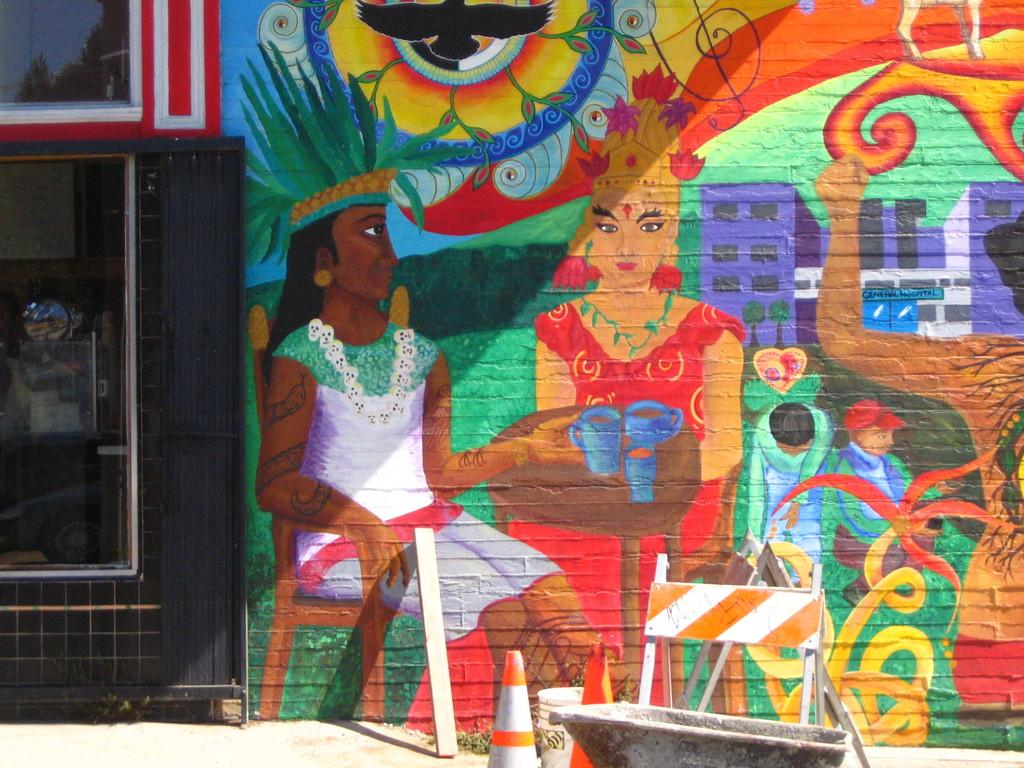What is present on the wall in the image? There is a painting on the wall in the image. What other objects can be seen in the image? There is a board, a bucket, traffic cones, and a tub in the image. Is there any barrier or divider visible in the image? Yes, there is a fence on the left side of the image. Can you see a squirrel playing chess with the idea of winning in the image? No, there is no squirrel or chess game present in the image. 